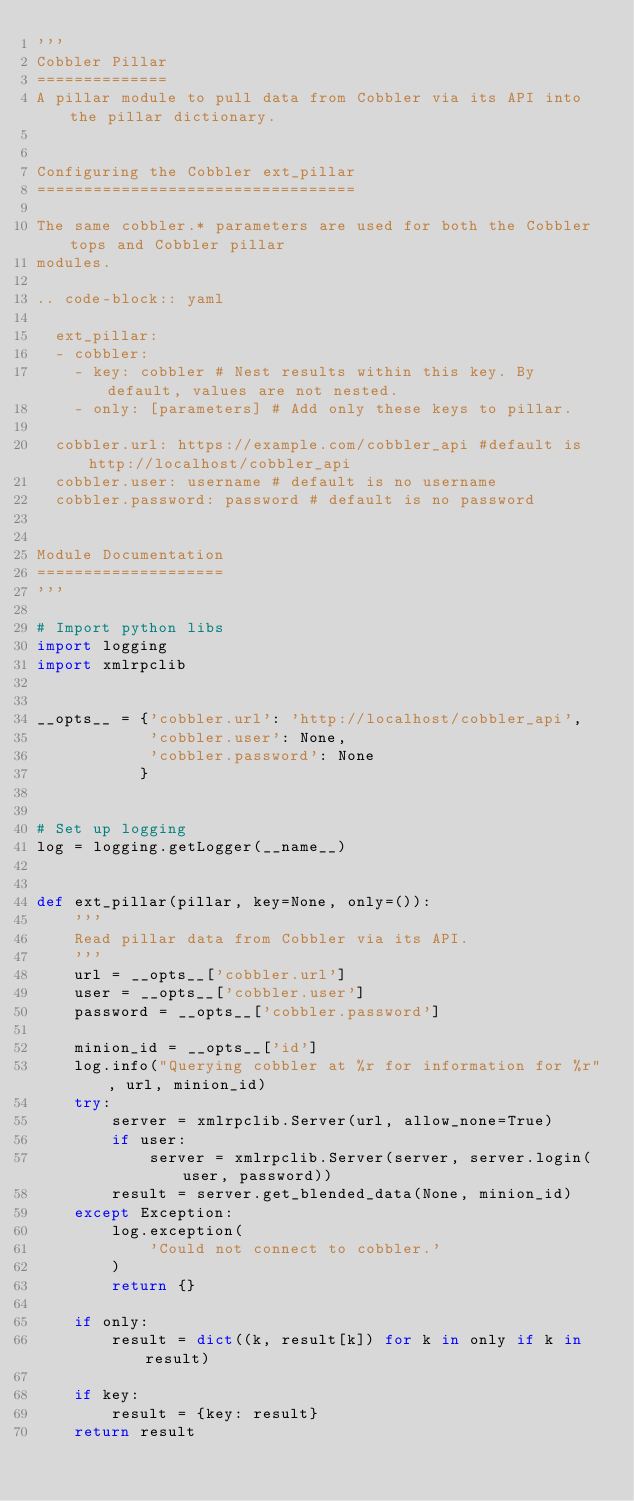Convert code to text. <code><loc_0><loc_0><loc_500><loc_500><_Python_>'''
Cobbler Pillar
==============
A pillar module to pull data from Cobbler via its API into the pillar dictionary.


Configuring the Cobbler ext_pillar
==================================

The same cobbler.* parameters are used for both the Cobbler tops and Cobbler pillar
modules.

.. code-block:: yaml

  ext_pillar:
  - cobbler:
    - key: cobbler # Nest results within this key. By default, values are not nested.
    - only: [parameters] # Add only these keys to pillar.

  cobbler.url: https://example.com/cobbler_api #default is http://localhost/cobbler_api
  cobbler.user: username # default is no username
  cobbler.password: password # default is no password


Module Documentation
====================
'''

# Import python libs
import logging
import xmlrpclib


__opts__ = {'cobbler.url': 'http://localhost/cobbler_api',
            'cobbler.user': None,
            'cobbler.password': None
           }


# Set up logging
log = logging.getLogger(__name__)


def ext_pillar(pillar, key=None, only=()):
    '''
    Read pillar data from Cobbler via its API.
    '''
    url = __opts__['cobbler.url']
    user = __opts__['cobbler.user']
    password = __opts__['cobbler.password']

    minion_id = __opts__['id']
    log.info("Querying cobbler at %r for information for %r", url, minion_id)
    try:
        server = xmlrpclib.Server(url, allow_none=True)
        if user:
            server = xmlrpclib.Server(server, server.login(user, password))
        result = server.get_blended_data(None, minion_id)
    except Exception:
        log.exception(
            'Could not connect to cobbler.'
        )
        return {}

    if only:
        result = dict((k, result[k]) for k in only if k in result)

    if key:
        result = {key: result}
    return result
</code> 